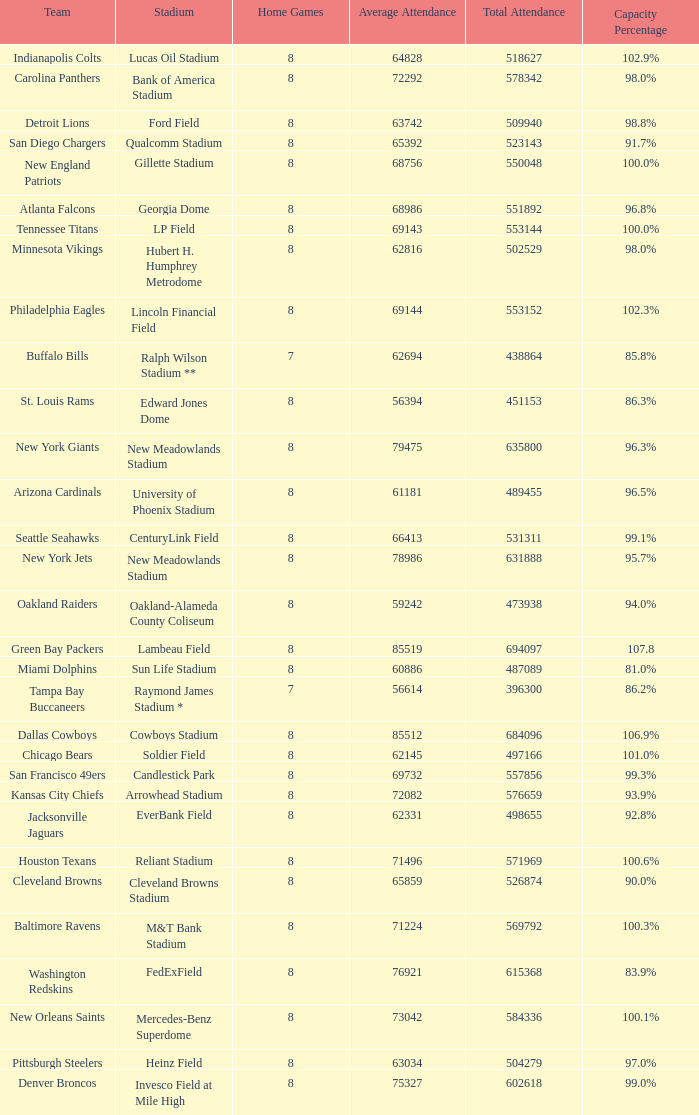What is the name of the stadium when the capacity percentage is 83.9% FedExField. 